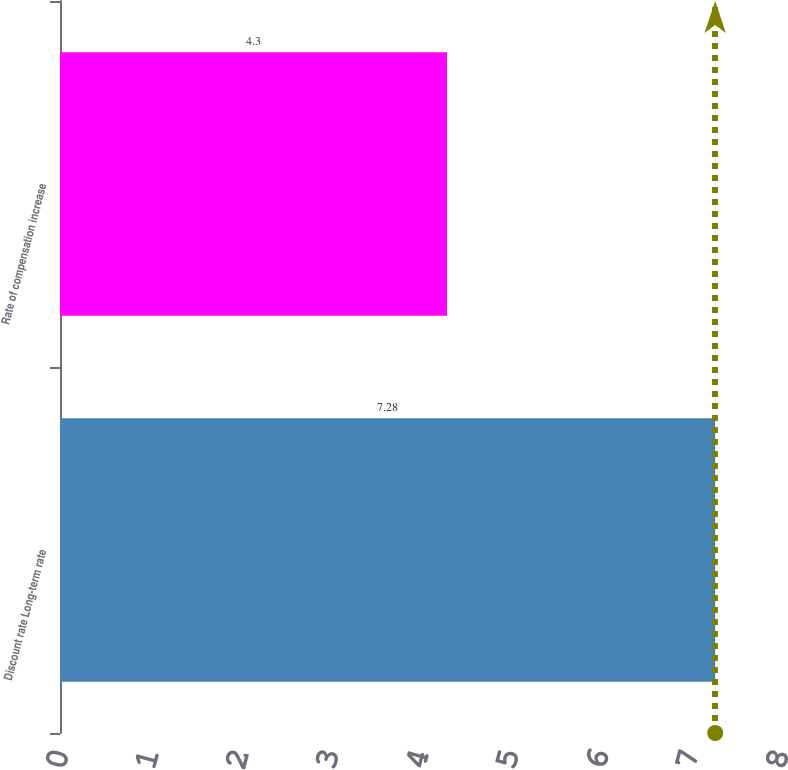Convert chart. <chart><loc_0><loc_0><loc_500><loc_500><bar_chart><fcel>Discount rate Long-term rate<fcel>Rate of compensation increase<nl><fcel>7.28<fcel>4.3<nl></chart> 